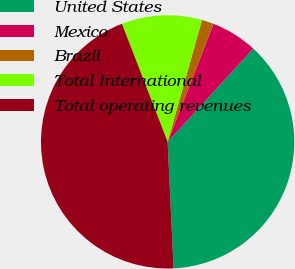<chart> <loc_0><loc_0><loc_500><loc_500><pie_chart><fcel>United States<fcel>Mexico<fcel>Brazil<fcel>Total International<fcel>Total operating revenues<nl><fcel>37.43%<fcel>5.92%<fcel>1.53%<fcel>10.25%<fcel>44.87%<nl></chart> 